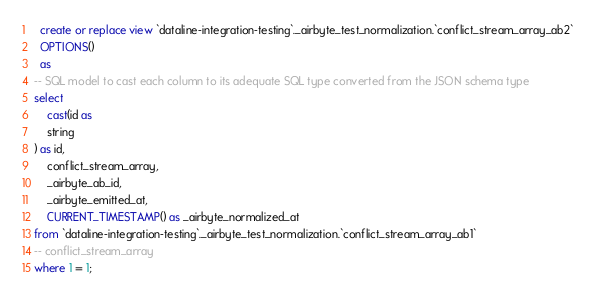Convert code to text. <code><loc_0><loc_0><loc_500><loc_500><_SQL_>

  create or replace view `dataline-integration-testing`._airbyte_test_normalization.`conflict_stream_array_ab2`
  OPTIONS()
  as 
-- SQL model to cast each column to its adequate SQL type converted from the JSON schema type
select
    cast(id as 
    string
) as id,
    conflict_stream_array,
    _airbyte_ab_id,
    _airbyte_emitted_at,
    CURRENT_TIMESTAMP() as _airbyte_normalized_at
from `dataline-integration-testing`._airbyte_test_normalization.`conflict_stream_array_ab1`
-- conflict_stream_array
where 1 = 1;

</code> 